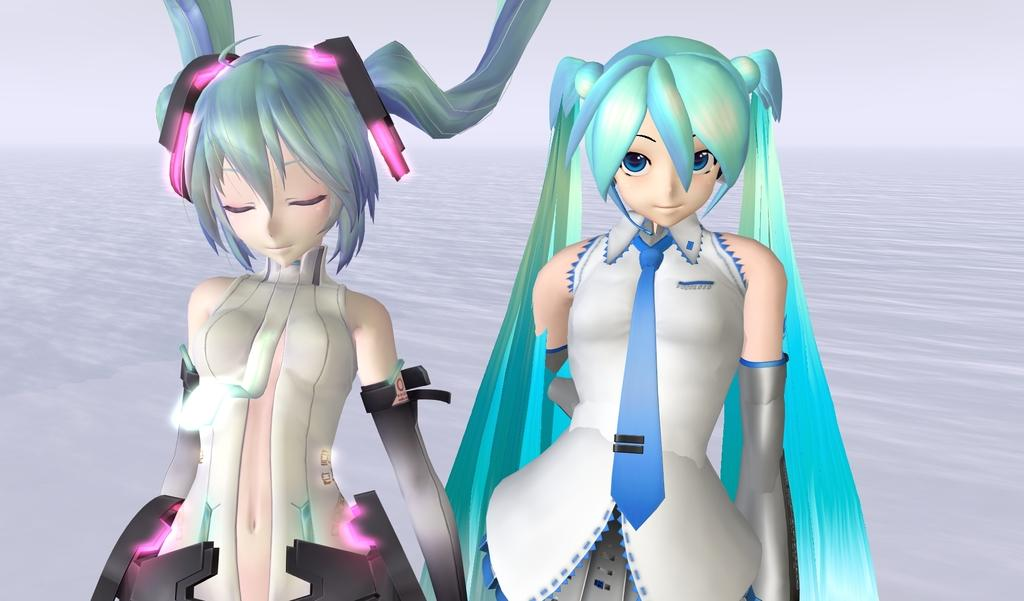What is depicted in the image? There are two animated pictures of girls in the image. Can you describe the background of the image? There is a white surface behind the girls. What type of humor can be seen in the girls' expressions in the image? There is no indication of humor or expressions on the girls' faces in the image, as they are animated pictures. What health benefits can be gained from looking at the image? There is no information about health benefits associated with looking at the image, as it only contains two animated pictures of girls on a white surface. 